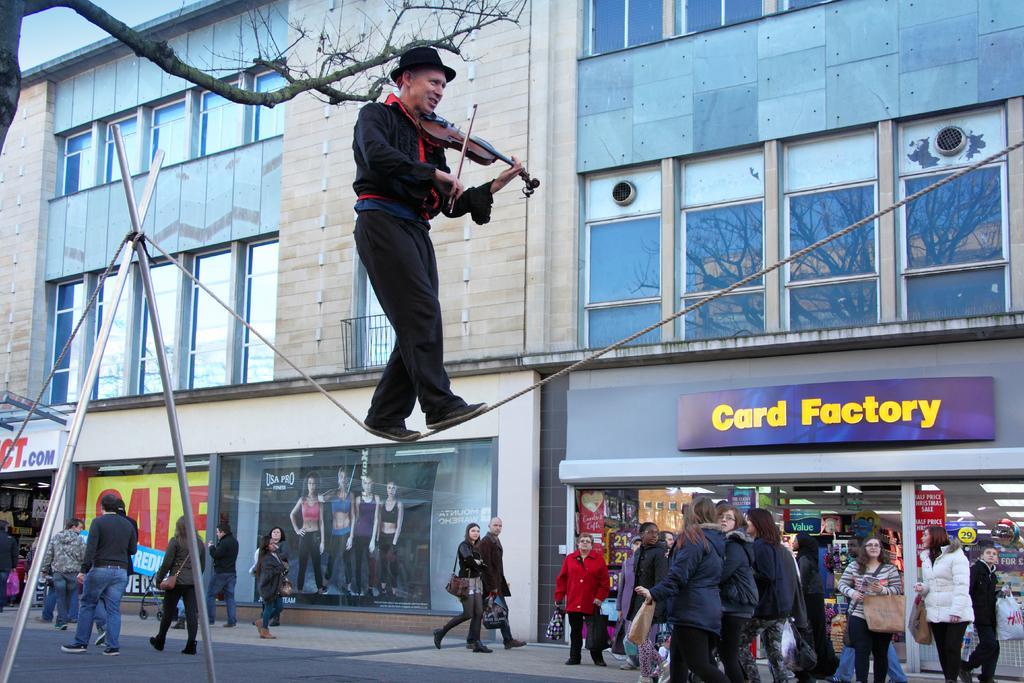Describe this image in one or two sentences. This is the picture of the outside of the city. On the right side we have a group of people. They are standing. In the center we have two persons. They both are walking like slowly. They are holding a bag. On the left side we have a group of people. They are walking like slowly. In the center we have person is standing on a rope. He is playing guitar and his holding stick. His wearing cap. we can see in the background there is a sky,trees and some bricks on white walls. 